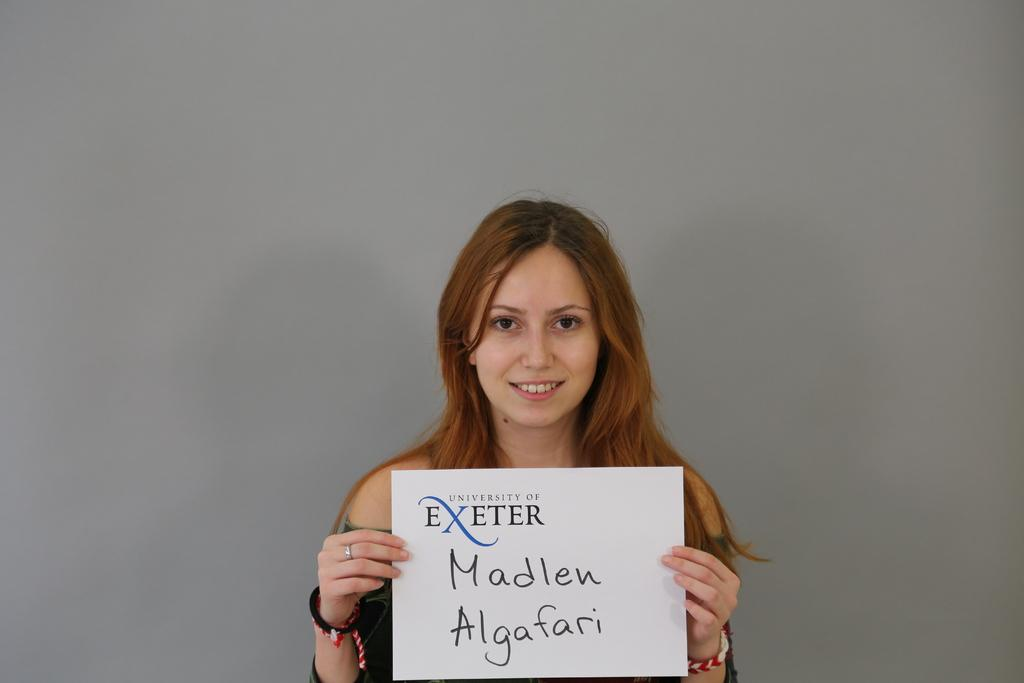Who is present in the image? There is a woman in the image. What is the woman doing in the image? The woman is smiling in the image. What is the woman holding in the image? The woman is holding a board in the image. What can be read on the board? There is text on the board. What can be seen in the background of the image? There is a wall visible in the background of the image. How does the woman sort the items on the board in the image? The image does not show the woman sorting any items on the board; she is simply holding it with a smile. 